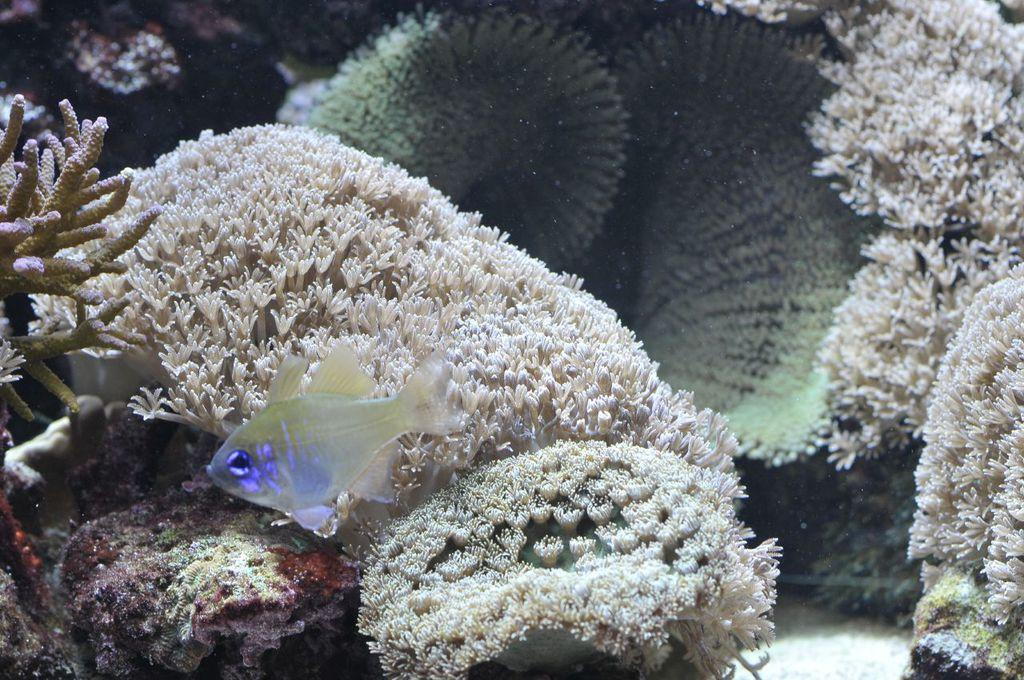Where was the image taken? The image is taken inside the water. What can be seen on the left side of the image? There is a fish on the left side of the image. What is visible in the background of the image? There are plants in the background of the image. What type of substance is being blown by the wind in the image? There is no wind or substance present in the image, as it is taken underwater. 